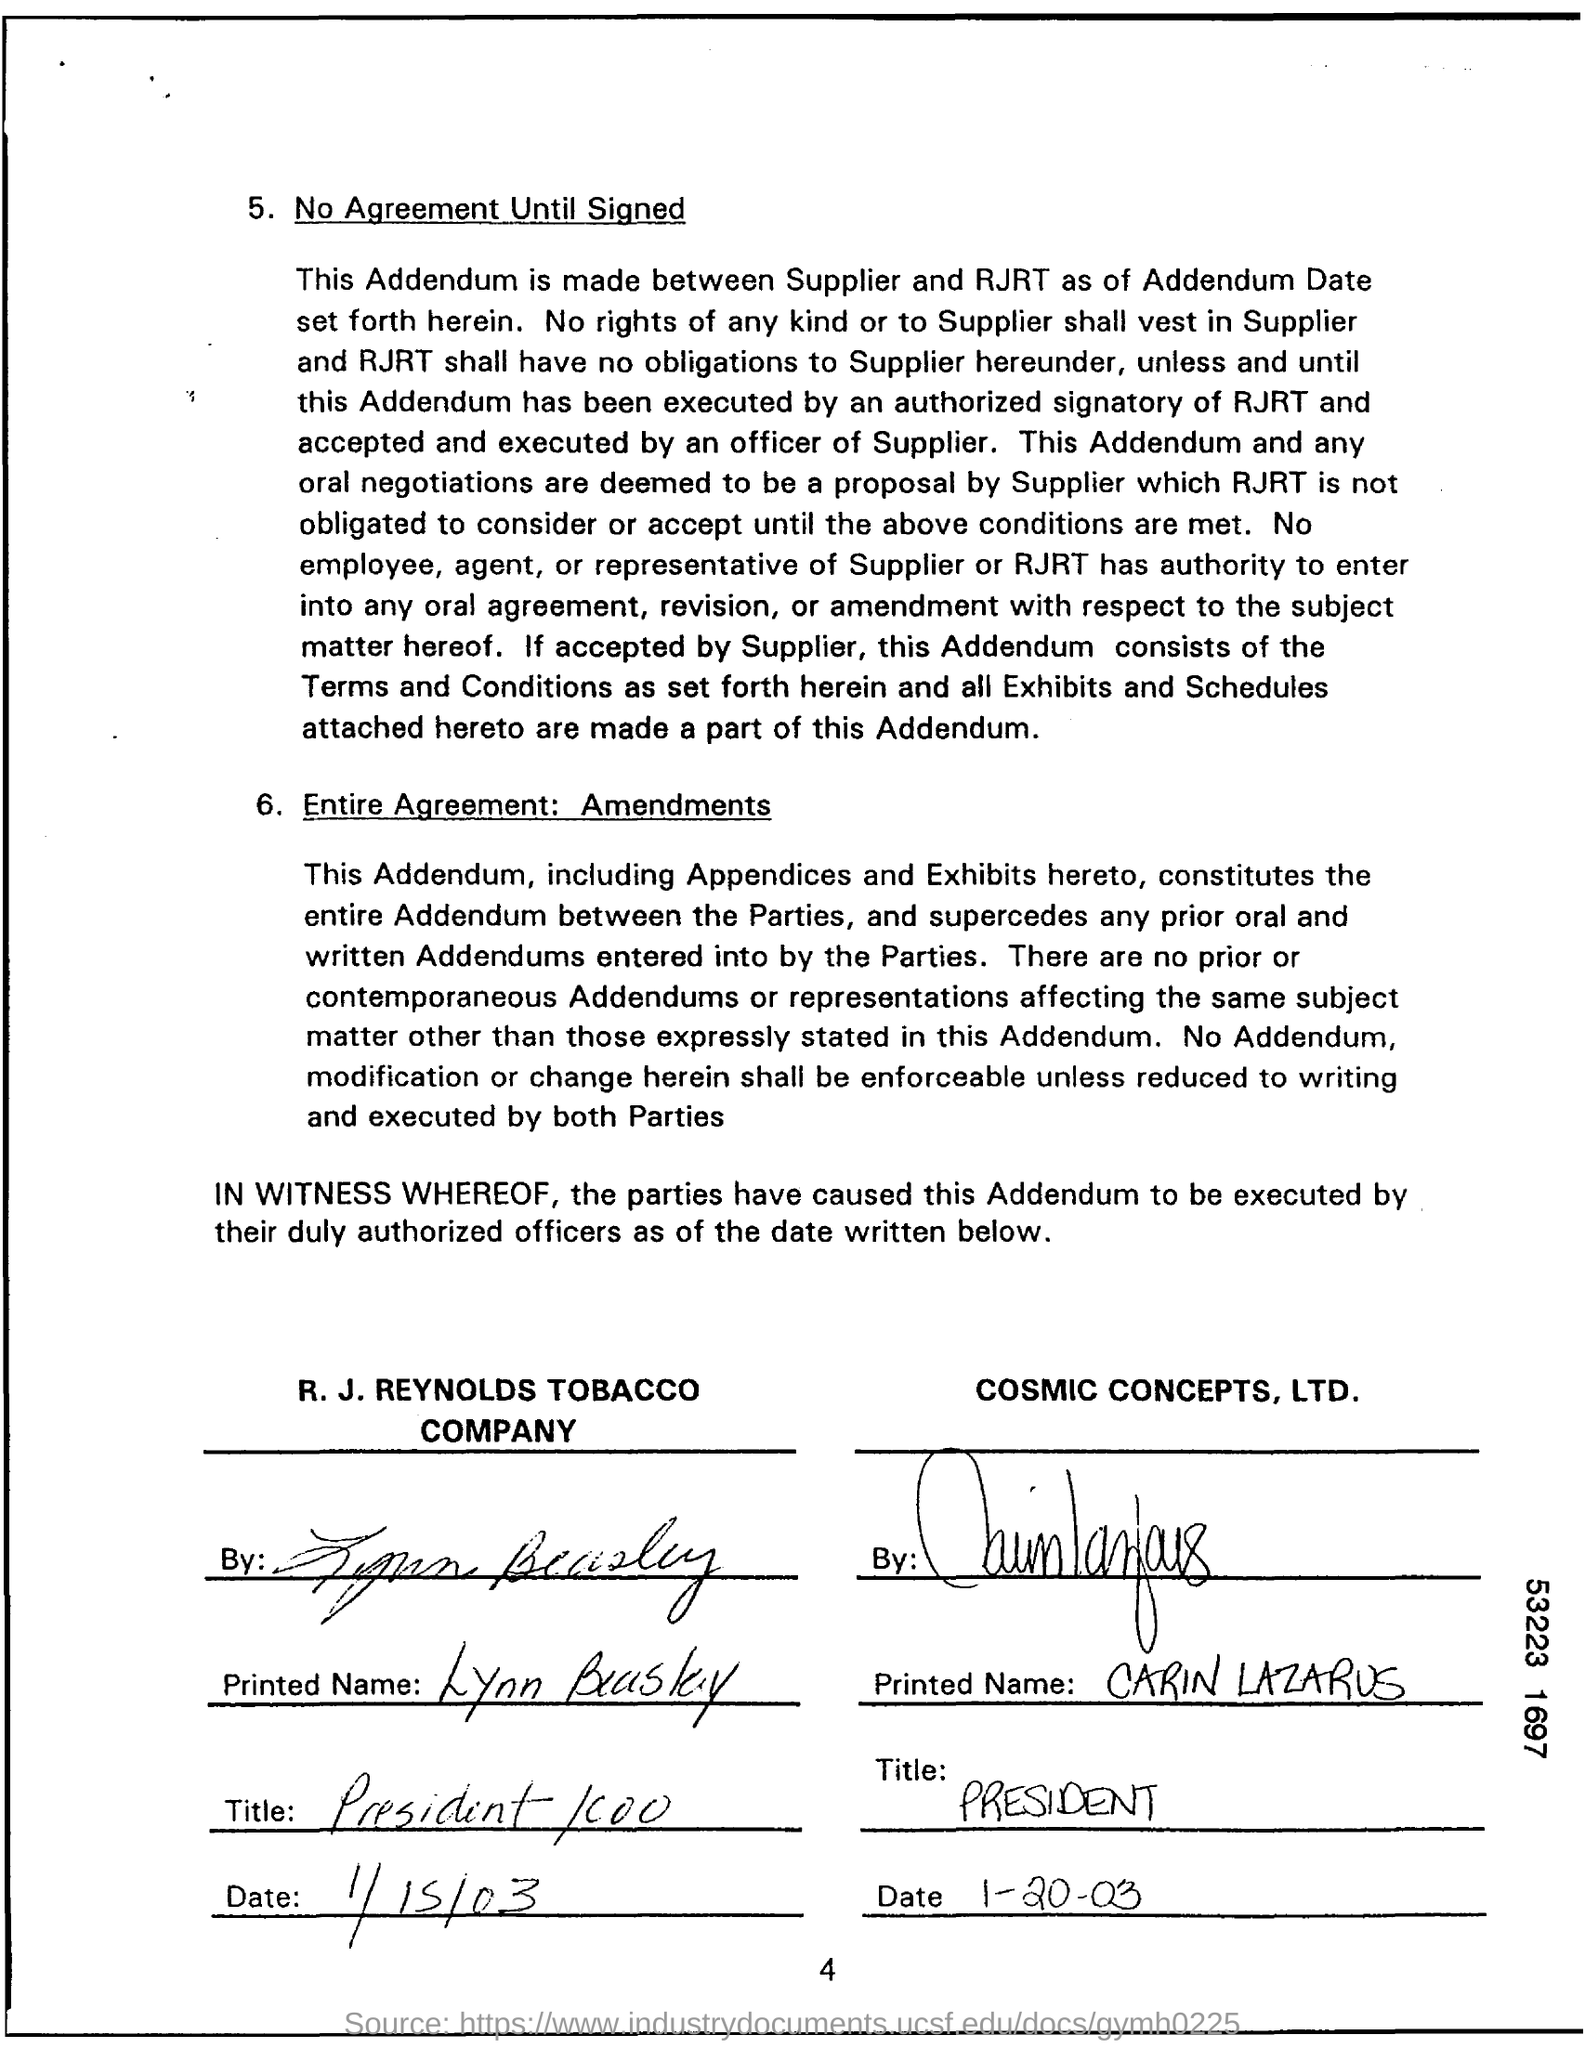Between whom is the Addendum made?
Your answer should be very brief. Supplier and RJRT. What is the title of CARIN LAZARUS?
Offer a terse response. President. Who is the supplier?
Offer a very short reply. COSMIC CONCEPTS, LTD. Who is the president/COO of R. J. Reynolds Tobacco Company?
Provide a short and direct response. Lynn Beasley. 